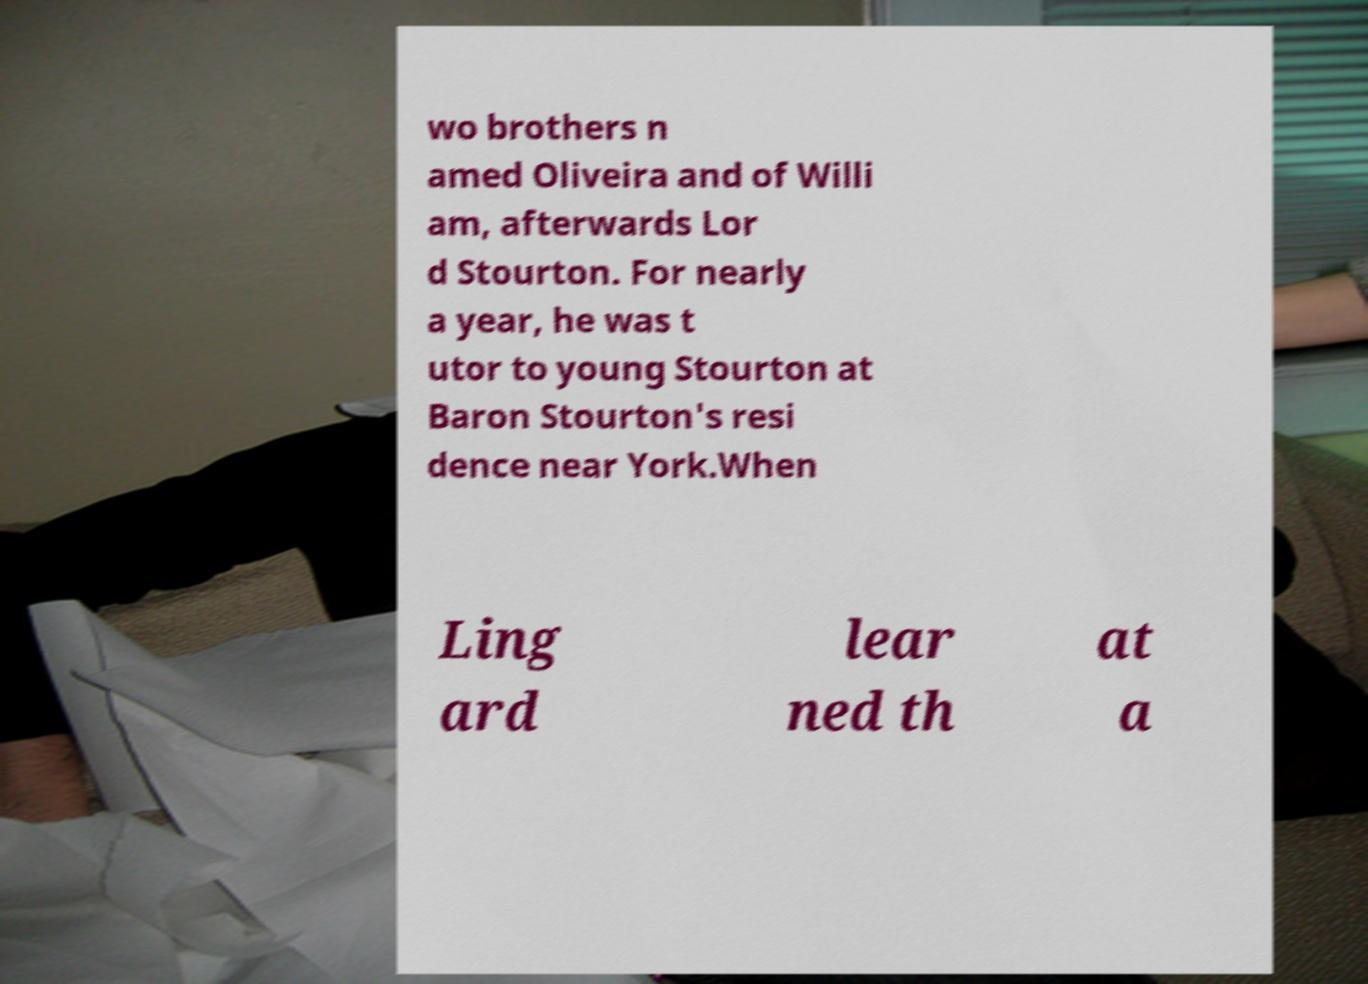Please read and relay the text visible in this image. What does it say? wo brothers n amed Oliveira and of Willi am, afterwards Lor d Stourton. For nearly a year, he was t utor to young Stourton at Baron Stourton's resi dence near York.When Ling ard lear ned th at a 